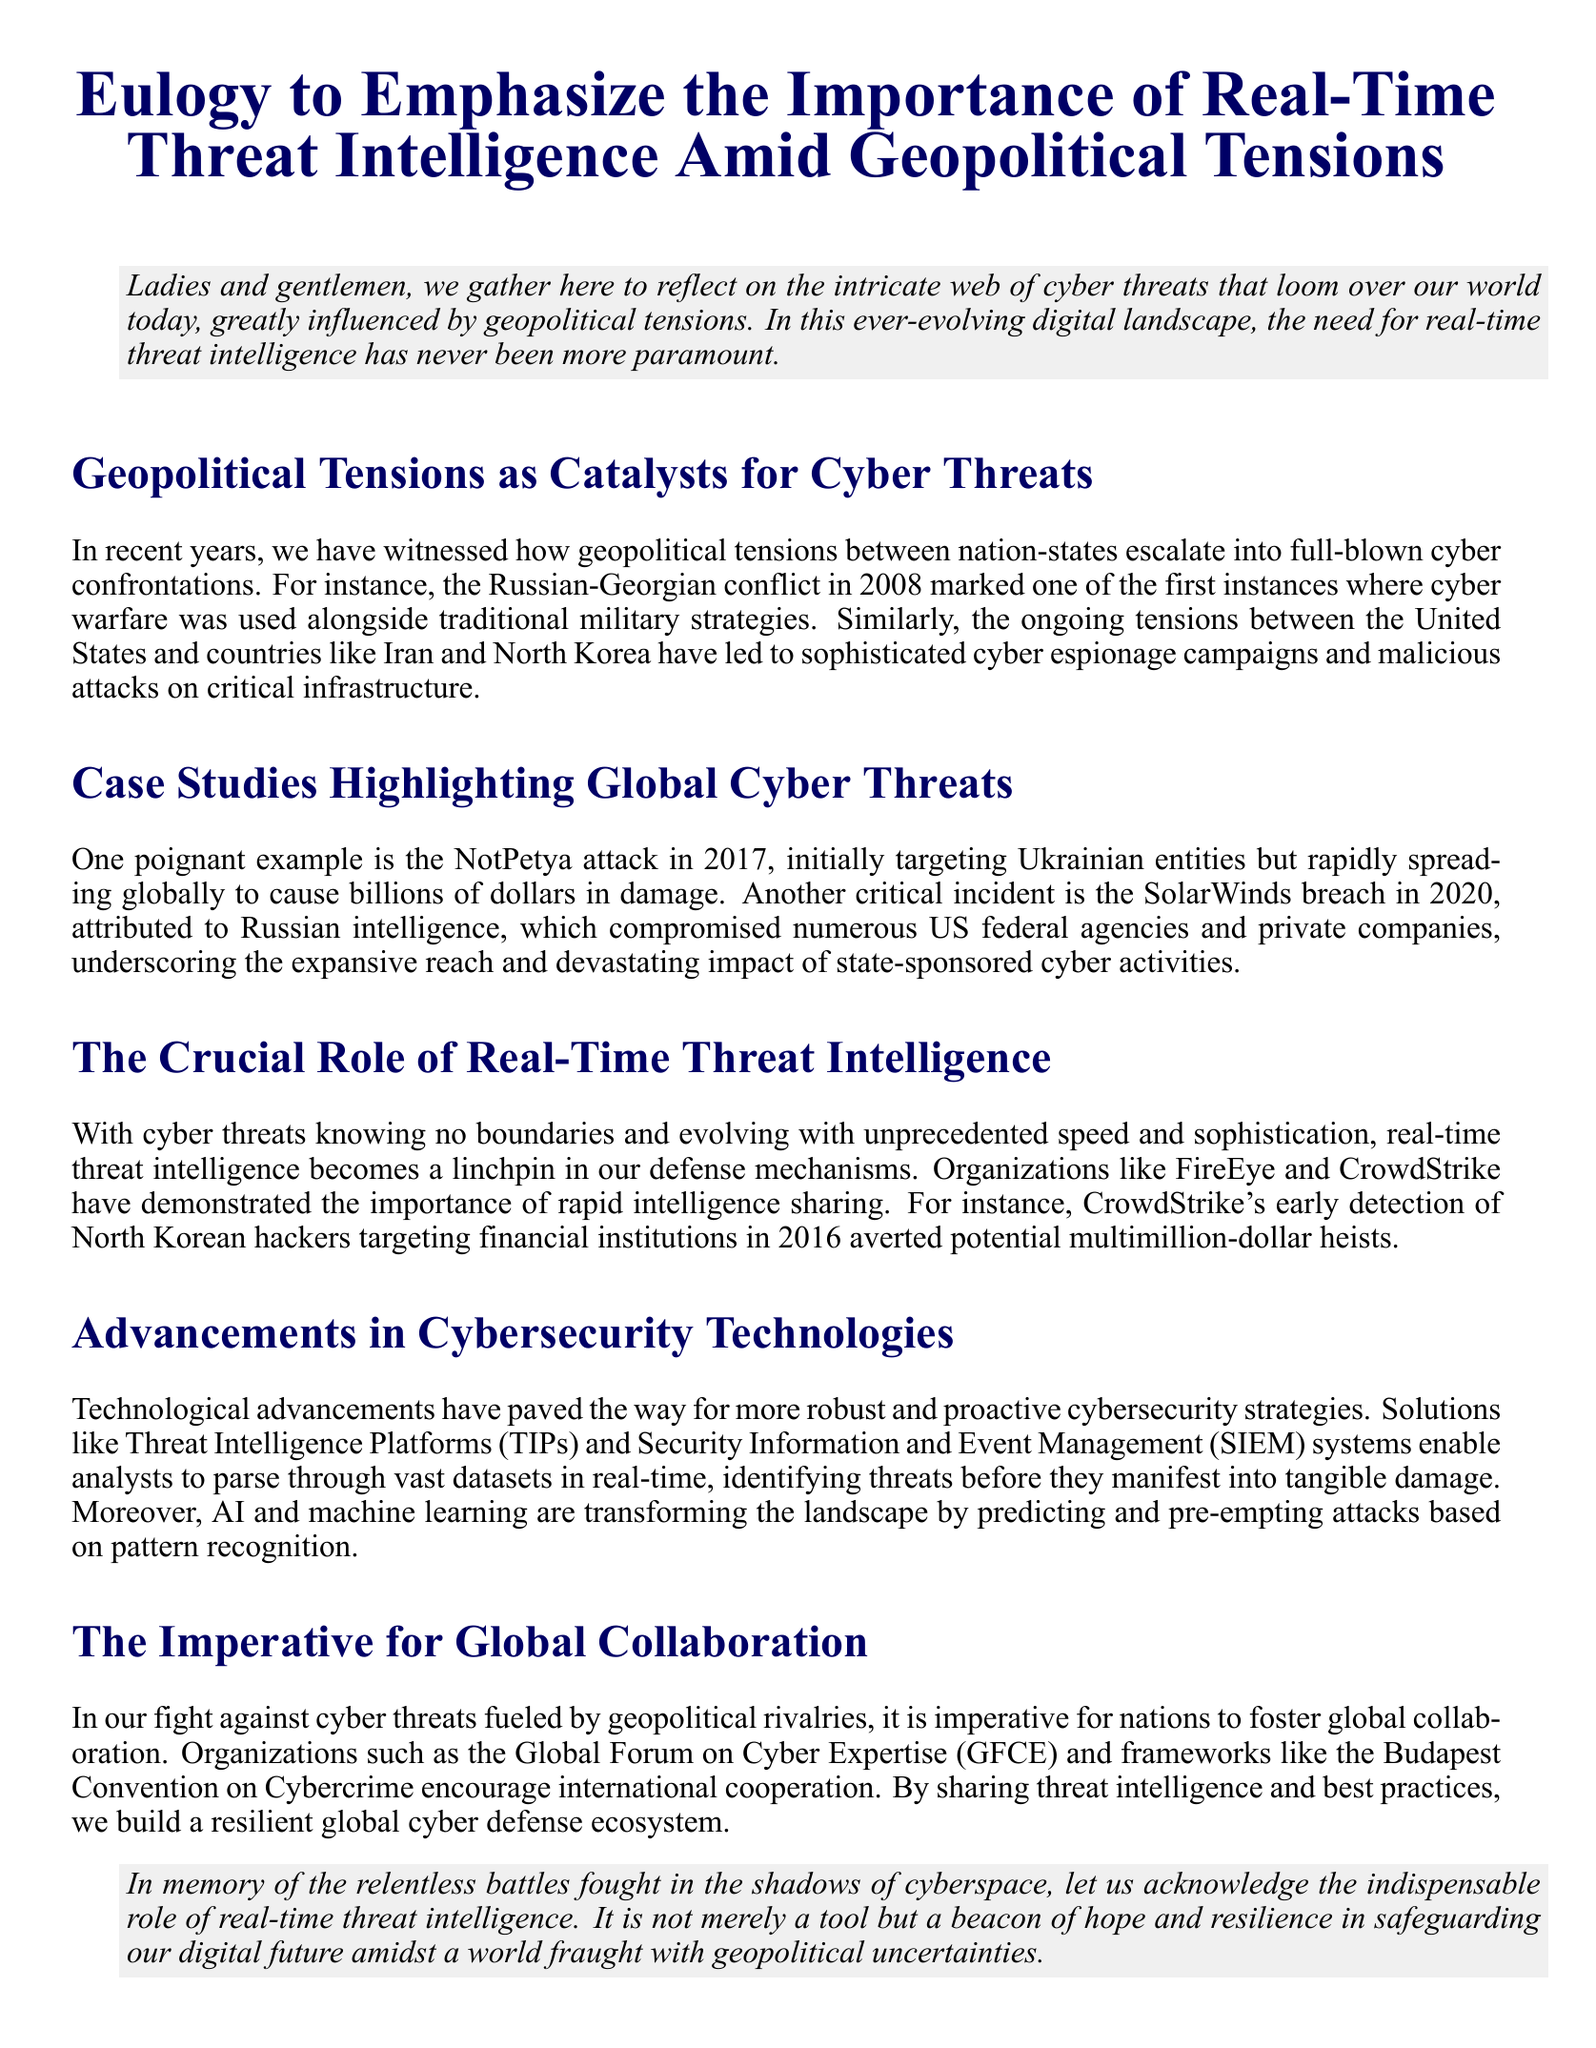What was the first instance of cyber warfare used alongside military strategies? The document mentions the Russian-Georgian conflict in 2008 as one of the first instances where cyber warfare was used alongside traditional military strategies.
Answer: Russian-Georgian conflict in 2008 What was the target of the NotPetya attack? The NotPetya attack initially targeted Ukrainian entities but affected many globally.
Answer: Ukrainian entities In what year did the SolarWinds breach occur? The document specifies that the SolarWinds breach occurred in 2020.
Answer: 2020 Which organization detected North Korean hackers in 2016? The document notes that CrowdStrike detected North Korean hackers targeting financial institutions in 2016.
Answer: CrowdStrike What are two examples of advanced cybersecurity technologies mentioned? The document references Threat Intelligence Platforms (TIPs) and Security Information and Event Management (SIEM) systems as advancements in cybersecurity technologies.
Answer: TIPs and SIEM systems What is a key role of real-time threat intelligence according to the document? It is described as a linchpin in defense mechanisms against rapidly evolving cyber threats.
Answer: Linchpin in defense mechanisms Which organizations promote global collaboration in cybersecurity? The Global Forum on Cyber Expertise (GFCE) and the Budapest Convention on Cybercrime are mentioned as promoting international cooperation in cybersecurity.
Answer: GFCE and Budapest Convention What term is used to describe the battles fought in cyberspace? The document refers to them as "relentless battles fought in the shadows of cyberspace."
Answer: Relentless battles What overarching theme is reflected in this eulogy? The theme conveys the importance of real-time threat intelligence amidst geopolitical uncertainties.
Answer: Importance of real-time threat intelligence 